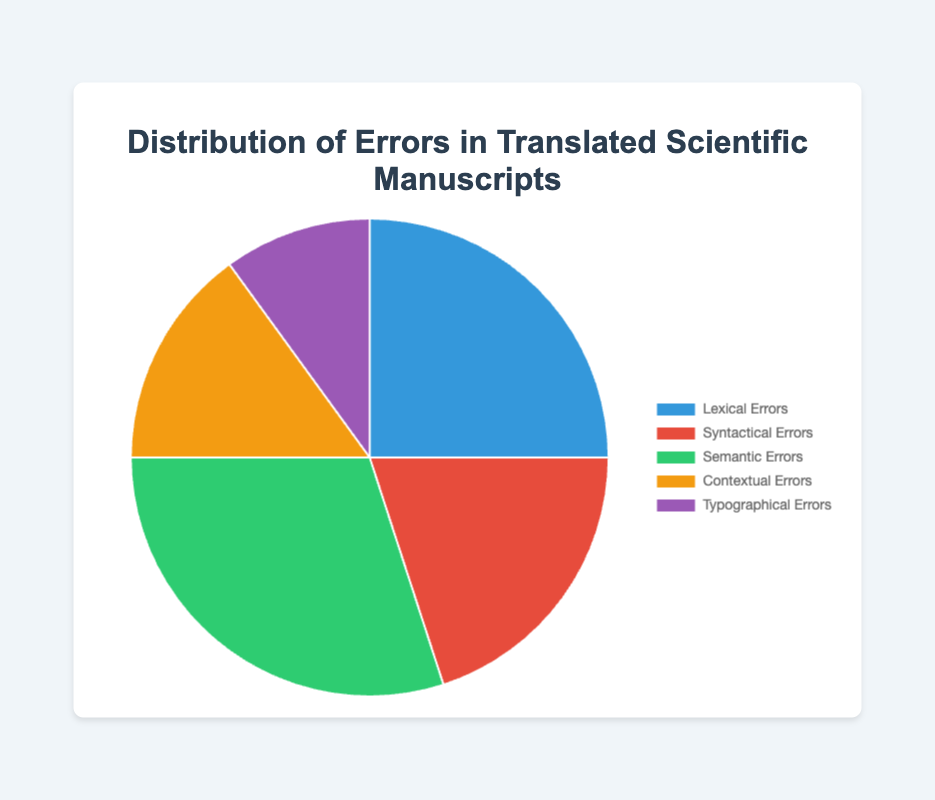Which error type has the highest percentage? By looking at the pie chart, we can determine which slice is the largest. The largest slice represents the error type with the highest percentage. This slice pertains to Semantic Errors, which has a percentage of 30%.
Answer: Semantic Errors What is the difference in percentage between Lexical Errors and Typographical Errors? To get the difference, subtract the percentage of Typographical Errors from the percentage of Lexical Errors. Lexical Errors have 25%, and Typographical Errors have 10%. So, 25% - 10% = 15%.
Answer: 15% Which types of errors have a combined percentage of 50%? We need to look at combinations whose percentages add up to 50%. Lexical Errors (25%) and Syntactical Errors (20%) combine to 45%. Syntactical Errors (20%) and Contextual Errors (15%) combine to 35%. Lexical Errors (25%) and Contextual Errors (15%) combine to 40%. Lexical Errors (25%) and Typographical Errors (10%) combine to 35%. Semantic Errors (30%) and Contextual Errors (15%) combine to 45%. Therefore, no exact combination adds up to 50%. There are no applicable combinations that sum up to 50%.
Answer: None Are the percentages of Syntactical Errors and Contextual Errors equal when added together more than the percentage of Semantic Errors? First, add the percentages of Syntactical Errors (20%) and Contextual Errors (15%). This gives us 20% + 15% = 35%. Then, compare it to the percentage of Semantic Errors, which is 30%. Since 35% > 30%, the combined percentage of Syntactical Errors and Contextual Errors is greater than that of Semantic Errors.
Answer: Yes Which error type is represented by the green color in the chart? The pie chart uses different colors to represent each error type. The error type represented by the green color is specified in the data, which corresponds to Semantic Errors. Thus, Semantic Errors are represented by the green color in the chart.
Answer: Semantic Errors What error types together make up exactly 50% of the total distribution? To determine which error types add up to exactly 50%, we look for combinations: Lexical Errors (25%) + Typographical Errors (10%) = 35%; Syntactical Errors (20%) + Contextual Errors (15%) = 35%; Typographical Errors (10%) + Semantic Errors (30%) = 40%. The combination of Lexical Errors (25%) and Syntactical Errors (20%) = 45% and close but no exact 50% combinations exist.
Answer: None What is the second most common error type? By examining the sizes of the slices, the largest corresponds to Semantic Errors at 30%, and the next largest slice is for Lexical Errors at 25%.
Answer: Lexical Errors 